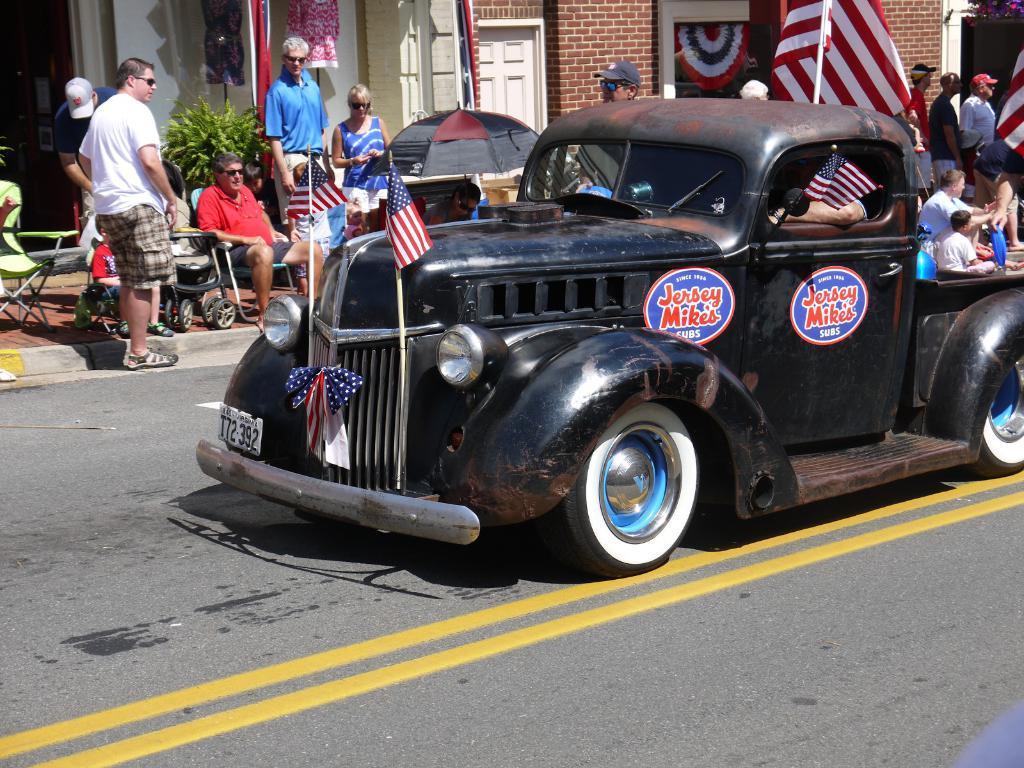Describe this image in one or two sentences. In the image we can see there is a car in which people are sitting and on the footpath people are sitting and standing. 